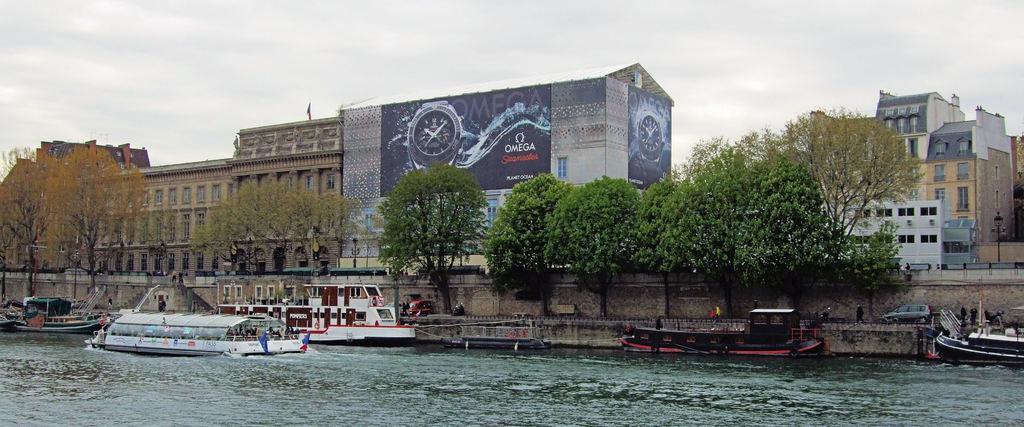Please provide a concise description of this image. In the foreground of the image we can see group of boats in water, a group of people standing on the ground, some cars are parked on the ground. In the center of the image we can see a group of trees. In the background a banner with some text on it, group of buildings with windows, light poles, barricades and the sky. 